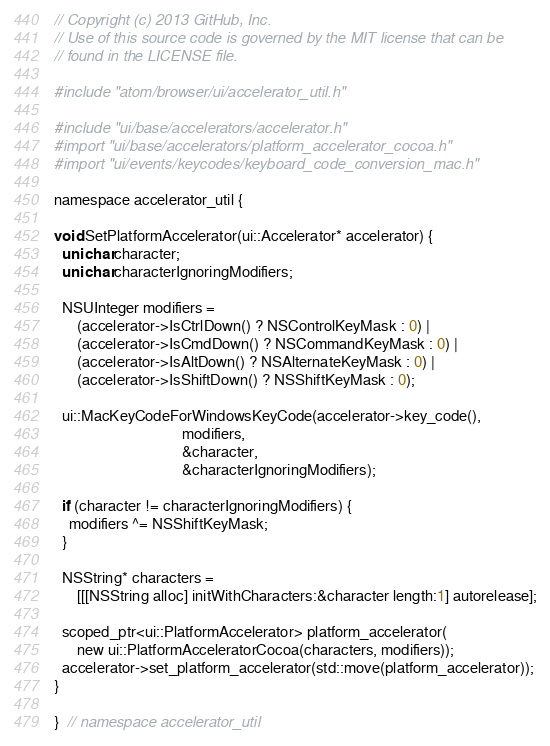<code> <loc_0><loc_0><loc_500><loc_500><_ObjectiveC_>// Copyright (c) 2013 GitHub, Inc.
// Use of this source code is governed by the MIT license that can be
// found in the LICENSE file.

#include "atom/browser/ui/accelerator_util.h"

#include "ui/base/accelerators/accelerator.h"
#import "ui/base/accelerators/platform_accelerator_cocoa.h"
#import "ui/events/keycodes/keyboard_code_conversion_mac.h"

namespace accelerator_util {

void SetPlatformAccelerator(ui::Accelerator* accelerator) {
  unichar character;
  unichar characterIgnoringModifiers;

  NSUInteger modifiers =
      (accelerator->IsCtrlDown() ? NSControlKeyMask : 0) |
      (accelerator->IsCmdDown() ? NSCommandKeyMask : 0) |
      (accelerator->IsAltDown() ? NSAlternateKeyMask : 0) |
      (accelerator->IsShiftDown() ? NSShiftKeyMask : 0);

  ui::MacKeyCodeForWindowsKeyCode(accelerator->key_code(),
                                  modifiers,
                                  &character,
                                  &characterIgnoringModifiers);

  if (character != characterIgnoringModifiers) {
    modifiers ^= NSShiftKeyMask;
  }

  NSString* characters =
      [[[NSString alloc] initWithCharacters:&character length:1] autorelease];

  scoped_ptr<ui::PlatformAccelerator> platform_accelerator(
      new ui::PlatformAcceleratorCocoa(characters, modifiers));
  accelerator->set_platform_accelerator(std::move(platform_accelerator));
}

}  // namespace accelerator_util
</code> 